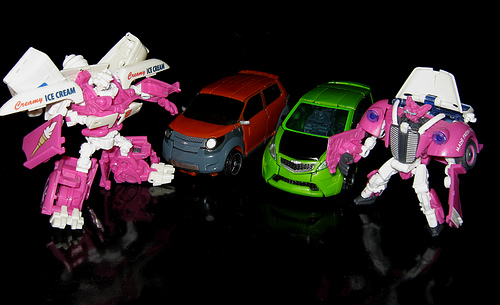<image>
Is there a toy on the car? No. The toy is not positioned on the car. They may be near each other, but the toy is not supported by or resting on top of the car. Is the car above the reflection? Yes. The car is positioned above the reflection in the vertical space, higher up in the scene. 